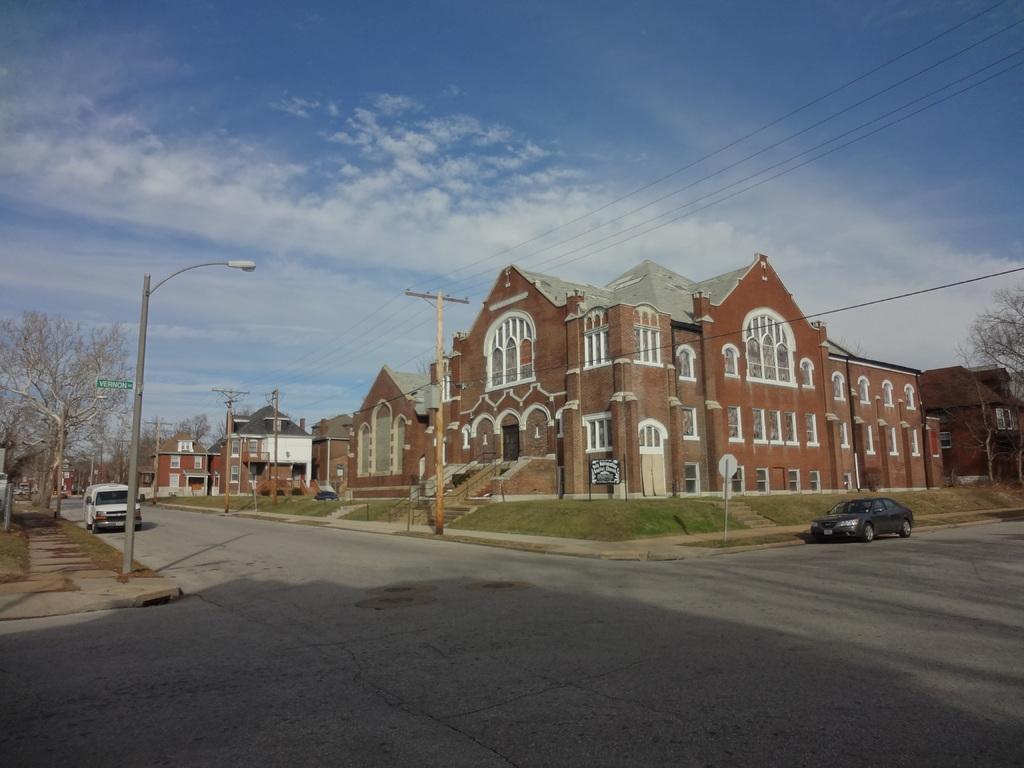In one or two sentences, can you explain what this image depicts? In this picture we can see the buildings, windows, roofs, poles, light, trees, vehicles, stairs, railing, glass, boards. At the bottom of the image we can see the road. At the top of the image we can see the wires and clouds are present in the sky. 